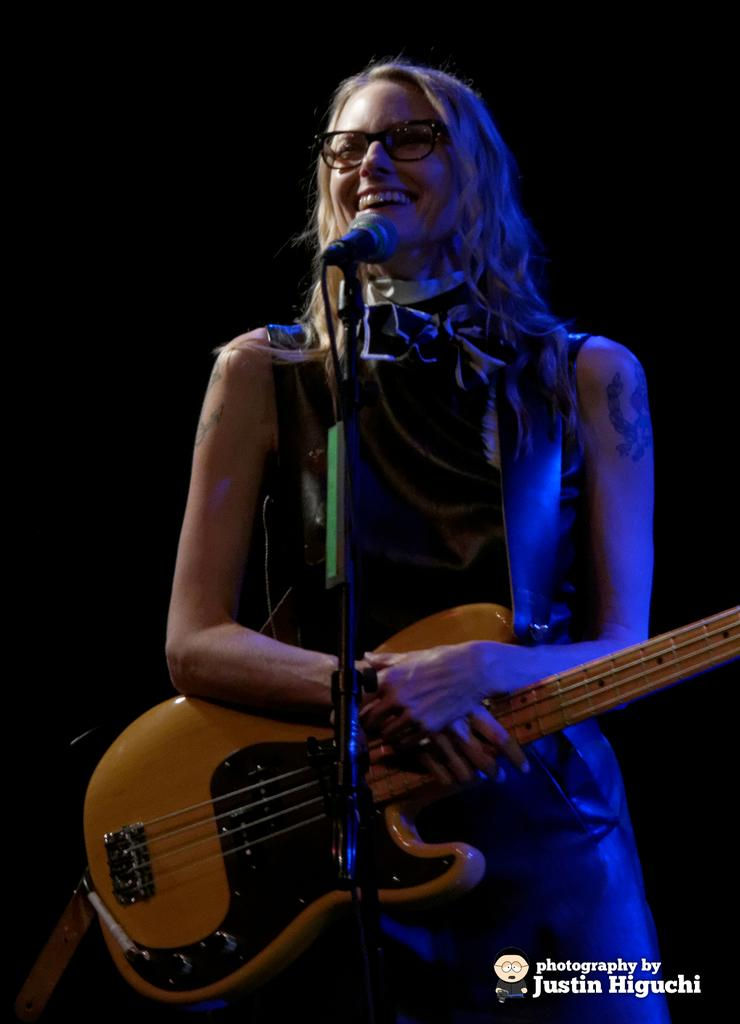What is the main subject of the image? The main subject of the image is a woman. What is the woman doing in the image? The woman is standing and wearing a guitar. What is the woman's facial expression in the image? The woman is smiling in the image. What other objects are present in the image? There is a microphone and a microphone stand in the image. Is there any text in the image? Yes, there is text in the image, specifically in the bottom right corner. What type of knee injury is the woman recovering from in the image? There is no indication of a knee injury or any medical condition in the image. 